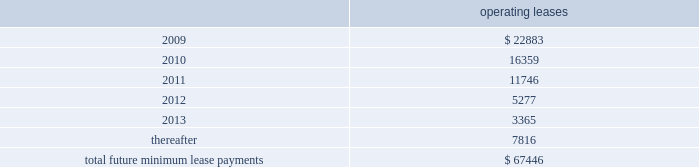Notes to consolidated financial statements 2014 ( continued ) note 12 2014related party transactions in the course of settling money transfer transactions , we purchase foreign currency from consultoria internacional casa de cambio ( 201ccisa 201d ) , a mexican company partially owned by certain of our employees .
As of march 31 , 2008 , mr .
Ra fal lim f3n cortes , a 10% ( 10 % ) shareholder of cisa , was no longer an employee , and we no longer considered cisa a related party .
We purchased 6.1 billion mexican pesos for $ 560.3 million during the ten months ended march 31 , 2008 and 8.1 billion mexican pesos for $ 736.0 million during fiscal 2007 from cisa .
We believe these currency transactions were executed at prevailing market exchange rates .
Also from time to time , money transfer transactions are settled at destination facilities owned by cisa .
We incurred related settlement expenses , included in cost of service in the accompanying consolidated statements of income of $ 0.5 million in the ten months ended march 31 , 2008 .
In fiscal 2007 and 2006 , we incurred related settlement expenses , included in cost of service in the accompanying consolidated statements of income of $ 0.7 and $ 0.6 million , respectively .
In the normal course of business , we periodically utilize the services of contractors to provide software development services .
One of our employees , hired in april 2005 , is also an employee , officer , and part owner of a firm that provides such services .
The services provided by this firm primarily relate to software development in connection with our planned next generation front-end processing system in the united states .
During fiscal 2008 , we capitalized fees paid to this firm of $ 0.3 million .
As of may 31 , 2008 and 2007 , capitalized amounts paid to this firm of $ 4.9 million and $ 4.6 million , respectively , were included in property and equipment in the accompanying consolidated balance sheets .
In addition , we expensed amounts paid to this firm of $ 0.3 million , $ 0.1 million and $ 0.5 million in the years ended may 31 , 2008 , 2007 and 2006 , respectively .
Note 13 2014commitments and contingencies leases we conduct a major part of our operations using leased facilities and equipment .
Many of these leases have renewal and purchase options and provide that we pay the cost of property taxes , insurance and maintenance .
Rent expense on all operating leases for fiscal 2008 , 2007 and 2006 was $ 30.4 million , $ 27.1 million , and $ 24.4 million , respectively .
Future minimum lease payments for all noncancelable leases at may 31 , 2008 were as follows : operating leases .
We are party to a number of other claims and lawsuits incidental to our business .
In the opinion of management , the reasonably possible outcome of such matters , individually or in the aggregate , will not have a material adverse impact on our financial position , liquidity or results of operations. .
What percentage of the future lease payments is has to be paid in 2009? 
Rationale: to figure out the percentage paid in 2009 , one must take the amount to be paid in 2009 and divide by the total amount to be paid .
Computations: (22883 / 67446)
Answer: 0.33928. 